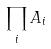<formula> <loc_0><loc_0><loc_500><loc_500>\prod _ { i } A _ { i }</formula> 